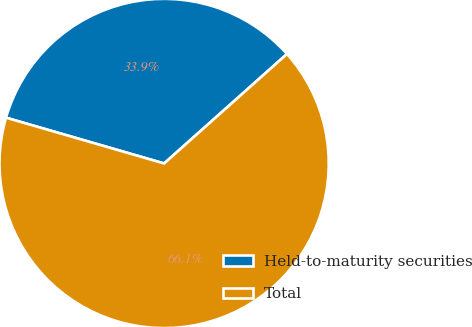<chart> <loc_0><loc_0><loc_500><loc_500><pie_chart><fcel>Held-to-maturity securities<fcel>Total<nl><fcel>33.93%<fcel>66.07%<nl></chart> 